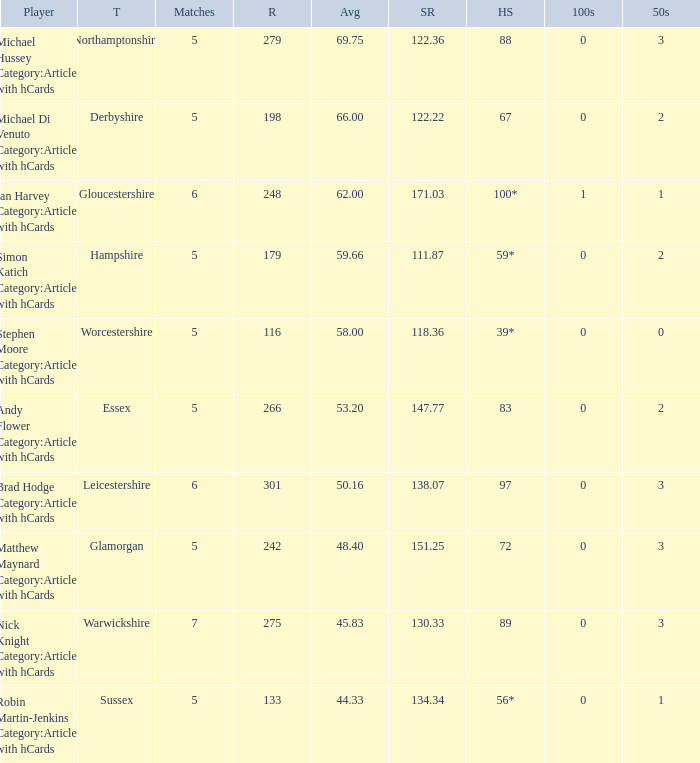16, who is the competitor? Brad Hodge Category:Articles with hCards. 